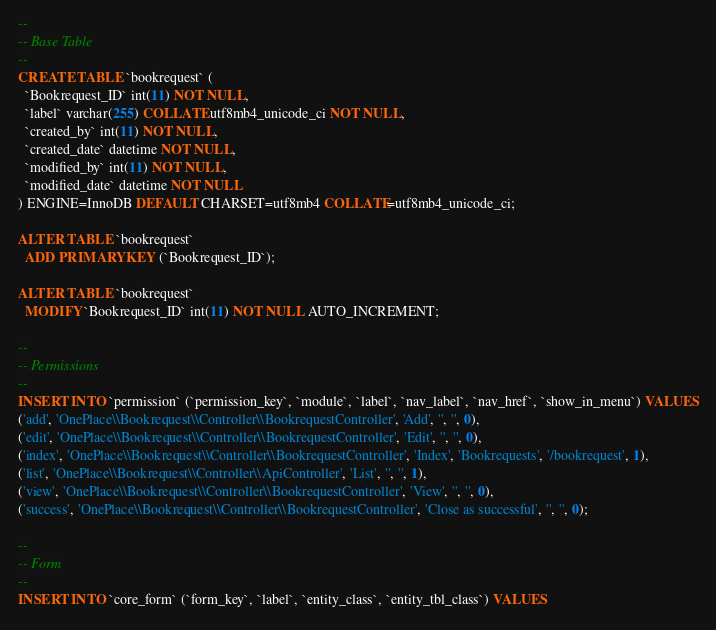<code> <loc_0><loc_0><loc_500><loc_500><_SQL_>--
-- Base Table
--
CREATE TABLE `bookrequest` (
  `Bookrequest_ID` int(11) NOT NULL,
  `label` varchar(255) COLLATE utf8mb4_unicode_ci NOT NULL,
  `created_by` int(11) NOT NULL,
  `created_date` datetime NOT NULL,
  `modified_by` int(11) NOT NULL,
  `modified_date` datetime NOT NULL
) ENGINE=InnoDB DEFAULT CHARSET=utf8mb4 COLLATE=utf8mb4_unicode_ci;

ALTER TABLE `bookrequest`
  ADD PRIMARY KEY (`Bookrequest_ID`);

ALTER TABLE `bookrequest`
  MODIFY `Bookrequest_ID` int(11) NOT NULL AUTO_INCREMENT;

--
-- Permissions
--
INSERT INTO `permission` (`permission_key`, `module`, `label`, `nav_label`, `nav_href`, `show_in_menu`) VALUES
('add', 'OnePlace\\Bookrequest\\Controller\\BookrequestController', 'Add', '', '', 0),
('edit', 'OnePlace\\Bookrequest\\Controller\\BookrequestController', 'Edit', '', '', 0),
('index', 'OnePlace\\Bookrequest\\Controller\\BookrequestController', 'Index', 'Bookrequests', '/bookrequest', 1),
('list', 'OnePlace\\Bookrequest\\Controller\\ApiController', 'List', '', '', 1),
('view', 'OnePlace\\Bookrequest\\Controller\\BookrequestController', 'View', '', '', 0),
('success', 'OnePlace\\Bookrequest\\Controller\\BookrequestController', 'Close as successful', '', '', 0);

--
-- Form
--
INSERT INTO `core_form` (`form_key`, `label`, `entity_class`, `entity_tbl_class`) VALUES</code> 